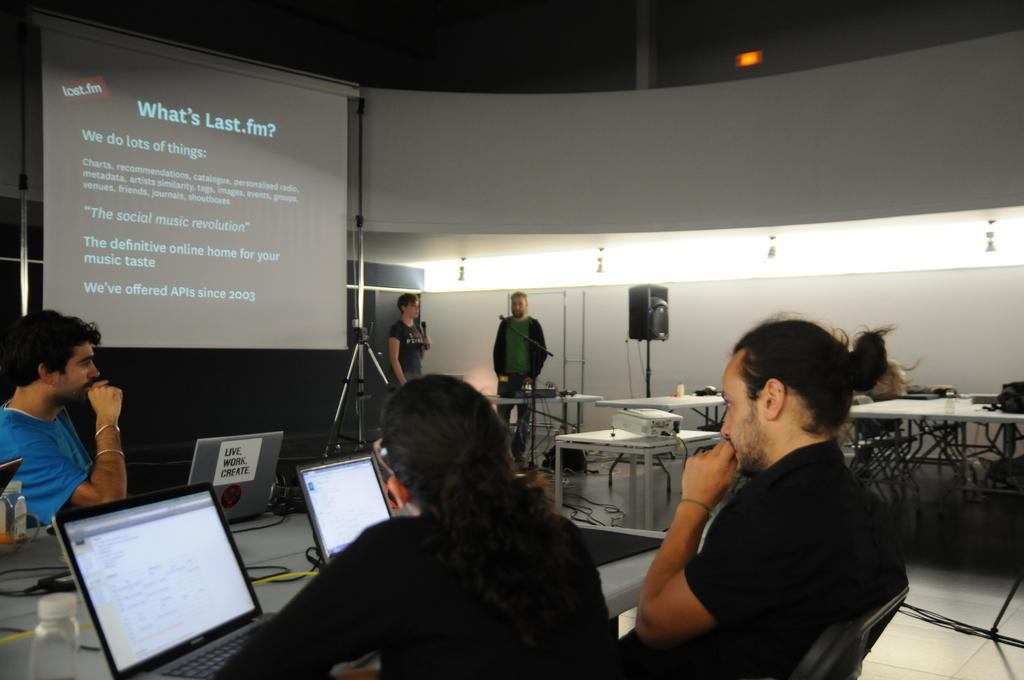<image>
Provide a brief description of the given image. Classroom where a presentation is being held and the slide titled What's Last .fm? being projected. 